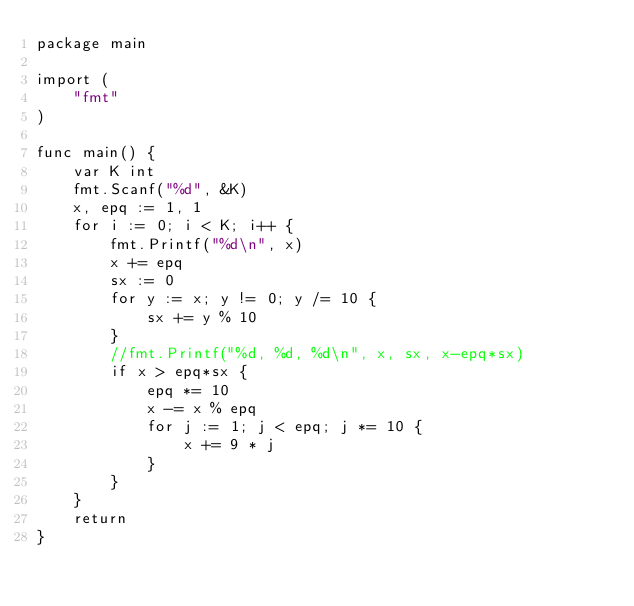<code> <loc_0><loc_0><loc_500><loc_500><_Go_>package main

import (
	"fmt"
)

func main() {
	var K int
	fmt.Scanf("%d", &K)
	x, epq := 1, 1
	for i := 0; i < K; i++ {
		fmt.Printf("%d\n", x)
		x += epq
		sx := 0
		for y := x; y != 0; y /= 10 {
			sx += y % 10
		}
		//fmt.Printf("%d, %d, %d\n", x, sx, x-epq*sx)
		if x > epq*sx {
			epq *= 10
			x -= x % epq
			for j := 1; j < epq; j *= 10 {
				x += 9 * j
			}
		}
	}
	return
}
</code> 